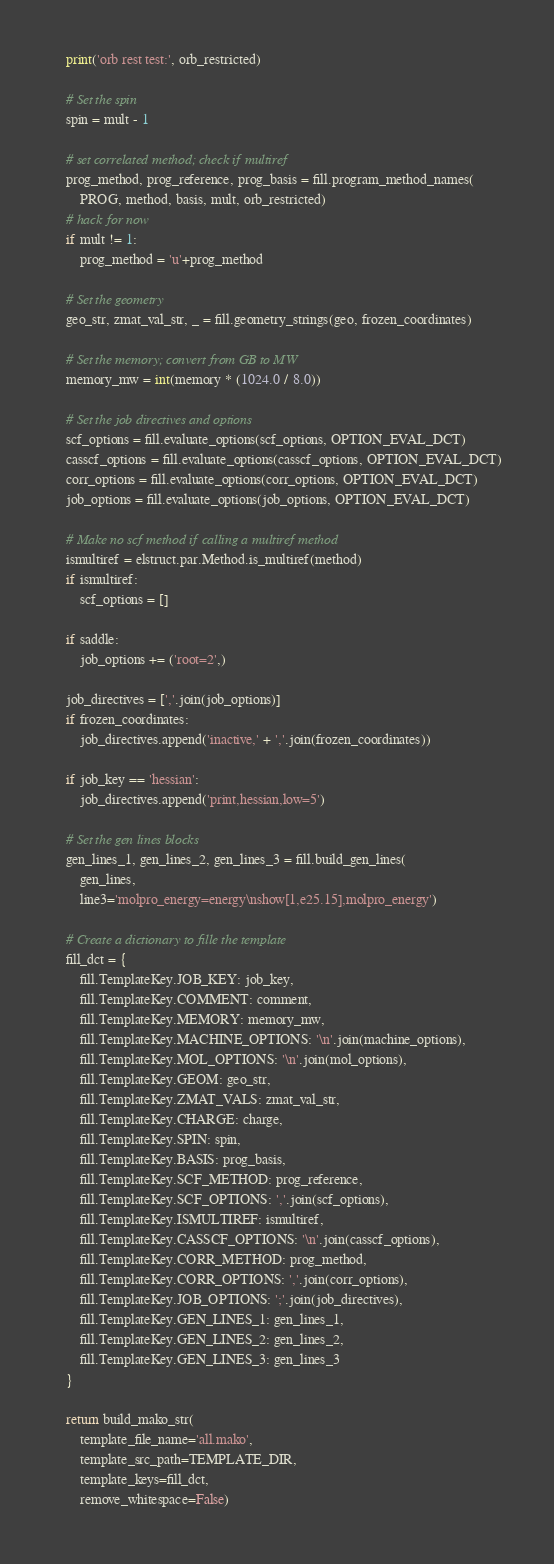Convert code to text. <code><loc_0><loc_0><loc_500><loc_500><_Python_>    print('orb rest test:', orb_restricted)

    # Set the spin
    spin = mult - 1

    # set correlated method; check if multiref
    prog_method, prog_reference, prog_basis = fill.program_method_names(
        PROG, method, basis, mult, orb_restricted)
    # hack for now
    if mult != 1:
        prog_method = 'u'+prog_method

    # Set the geometry
    geo_str, zmat_val_str, _ = fill.geometry_strings(geo, frozen_coordinates)

    # Set the memory; convert from GB to MW
    memory_mw = int(memory * (1024.0 / 8.0))

    # Set the job directives and options
    scf_options = fill.evaluate_options(scf_options, OPTION_EVAL_DCT)
    casscf_options = fill.evaluate_options(casscf_options, OPTION_EVAL_DCT)
    corr_options = fill.evaluate_options(corr_options, OPTION_EVAL_DCT)
    job_options = fill.evaluate_options(job_options, OPTION_EVAL_DCT)

    # Make no scf method if calling a multiref method
    ismultiref = elstruct.par.Method.is_multiref(method)
    if ismultiref:
        scf_options = []

    if saddle:
        job_options += ('root=2',)

    job_directives = [','.join(job_options)]
    if frozen_coordinates:
        job_directives.append('inactive,' + ','.join(frozen_coordinates))

    if job_key == 'hessian':
        job_directives.append('print,hessian,low=5')

    # Set the gen lines blocks
    gen_lines_1, gen_lines_2, gen_lines_3 = fill.build_gen_lines(
        gen_lines,
        line3='molpro_energy=energy\nshow[1,e25.15],molpro_energy')

    # Create a dictionary to fille the template
    fill_dct = {
        fill.TemplateKey.JOB_KEY: job_key,
        fill.TemplateKey.COMMENT: comment,
        fill.TemplateKey.MEMORY: memory_mw,
        fill.TemplateKey.MACHINE_OPTIONS: '\n'.join(machine_options),
        fill.TemplateKey.MOL_OPTIONS: '\n'.join(mol_options),
        fill.TemplateKey.GEOM: geo_str,
        fill.TemplateKey.ZMAT_VALS: zmat_val_str,
        fill.TemplateKey.CHARGE: charge,
        fill.TemplateKey.SPIN: spin,
        fill.TemplateKey.BASIS: prog_basis,
        fill.TemplateKey.SCF_METHOD: prog_reference,
        fill.TemplateKey.SCF_OPTIONS: ','.join(scf_options),
        fill.TemplateKey.ISMULTIREF: ismultiref,
        fill.TemplateKey.CASSCF_OPTIONS: '\n'.join(casscf_options),
        fill.TemplateKey.CORR_METHOD: prog_method,
        fill.TemplateKey.CORR_OPTIONS: ','.join(corr_options),
        fill.TemplateKey.JOB_OPTIONS: ';'.join(job_directives),
        fill.TemplateKey.GEN_LINES_1: gen_lines_1,
        fill.TemplateKey.GEN_LINES_2: gen_lines_2,
        fill.TemplateKey.GEN_LINES_3: gen_lines_3
    }

    return build_mako_str(
        template_file_name='all.mako',
        template_src_path=TEMPLATE_DIR,
        template_keys=fill_dct,
        remove_whitespace=False)
</code> 